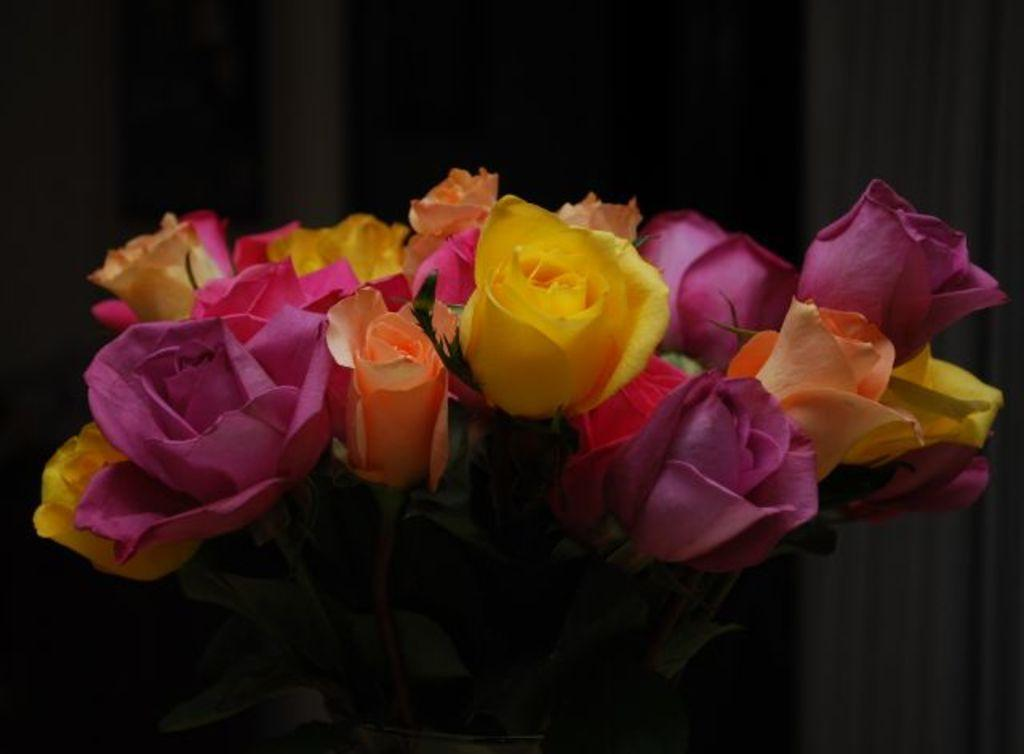What is the main subject of the image? The main subject of the image is a flower book. What can be found inside the flower book? The flower book contains many flowers. What is the variety of colors among the flowers in the book? The flowers are of different colors. How would you describe the overall appearance of the image? The background of the image is dark. What type of line is being judged by the milk in the image? There is no line, judge, or milk present in the image. The image features a flower book with flowers of different colors against a dark background. 